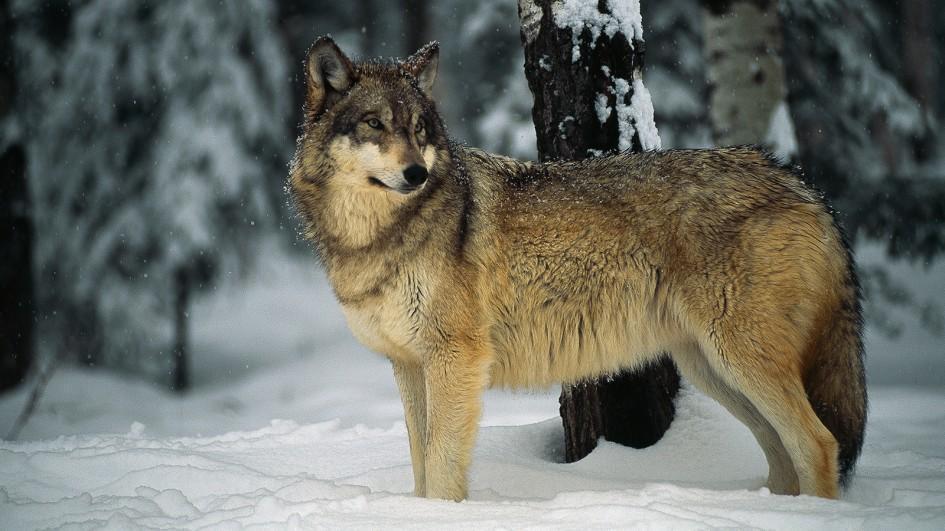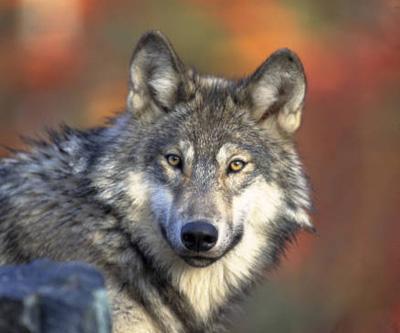The first image is the image on the left, the second image is the image on the right. Examine the images to the left and right. Is the description "The right image contains at least two wolves." accurate? Answer yes or no. No. 